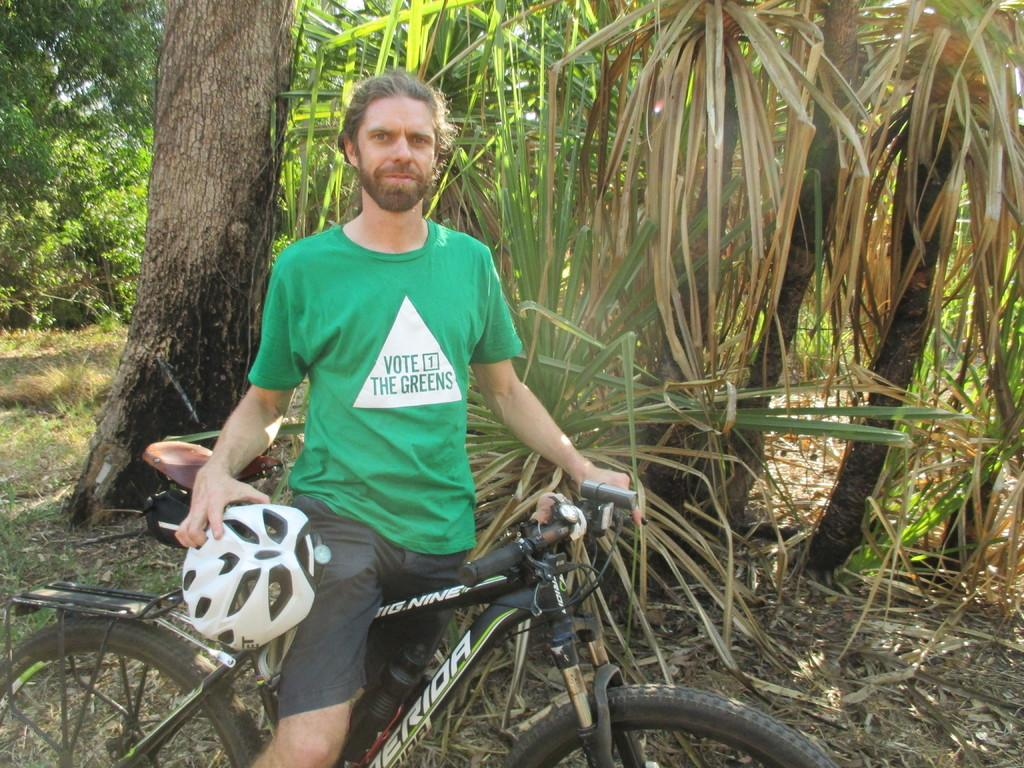What type of vegetation can be seen in the image? There are trees in the image. What mode of transportation is present in the image? There is a bicycle in the image. Who is in the image? There is a man in the image. What is the man holding? The man is holding a helmet. Where is the clock located in the image? There is no clock present in the image. What type of animal is the man riding in the image? There is no animal present in the image, including a donkey. 